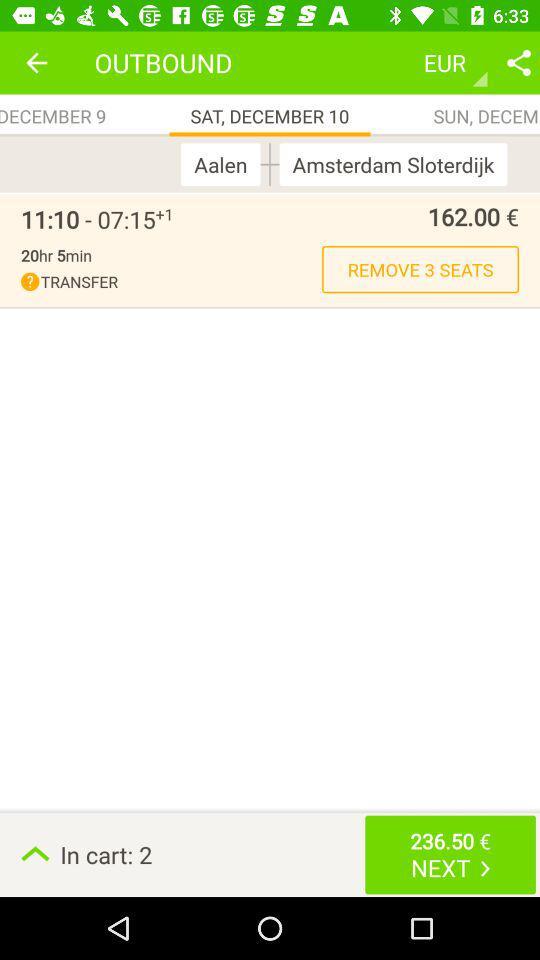Which option is selected? The selected option is "SAT, DECEMBER 10". 